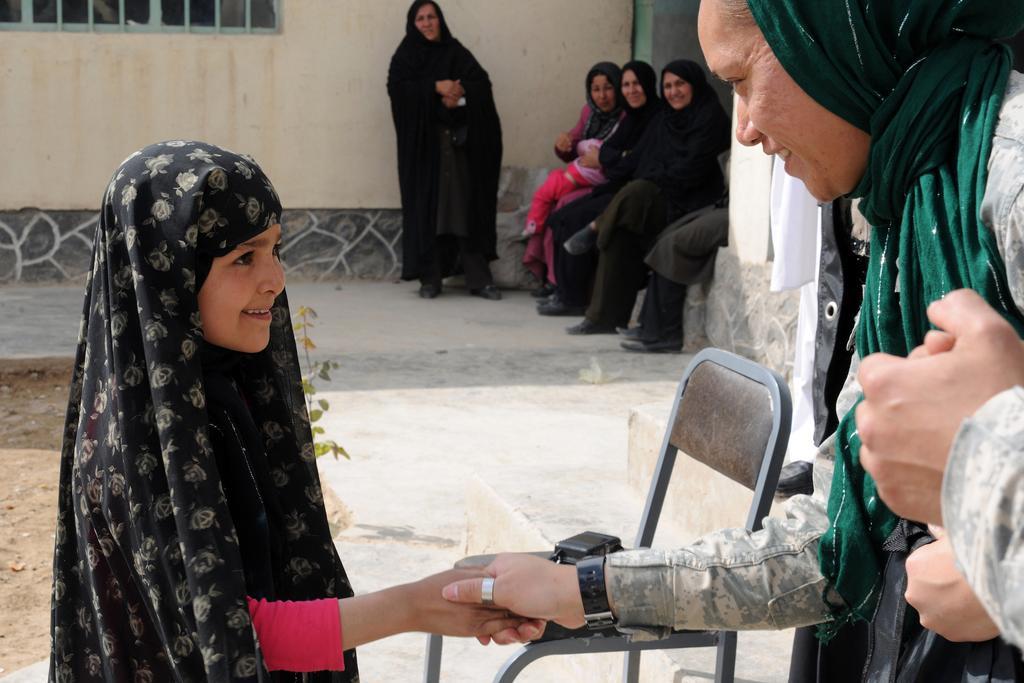Describe this image in one or two sentences. There are three women sitting and two women standing. This looks like a chair with an object on it. This woman is hand shaking with the girl. I think this is a building wall. On the right side of the image, I can see a person's hand. This looks like a plant. 